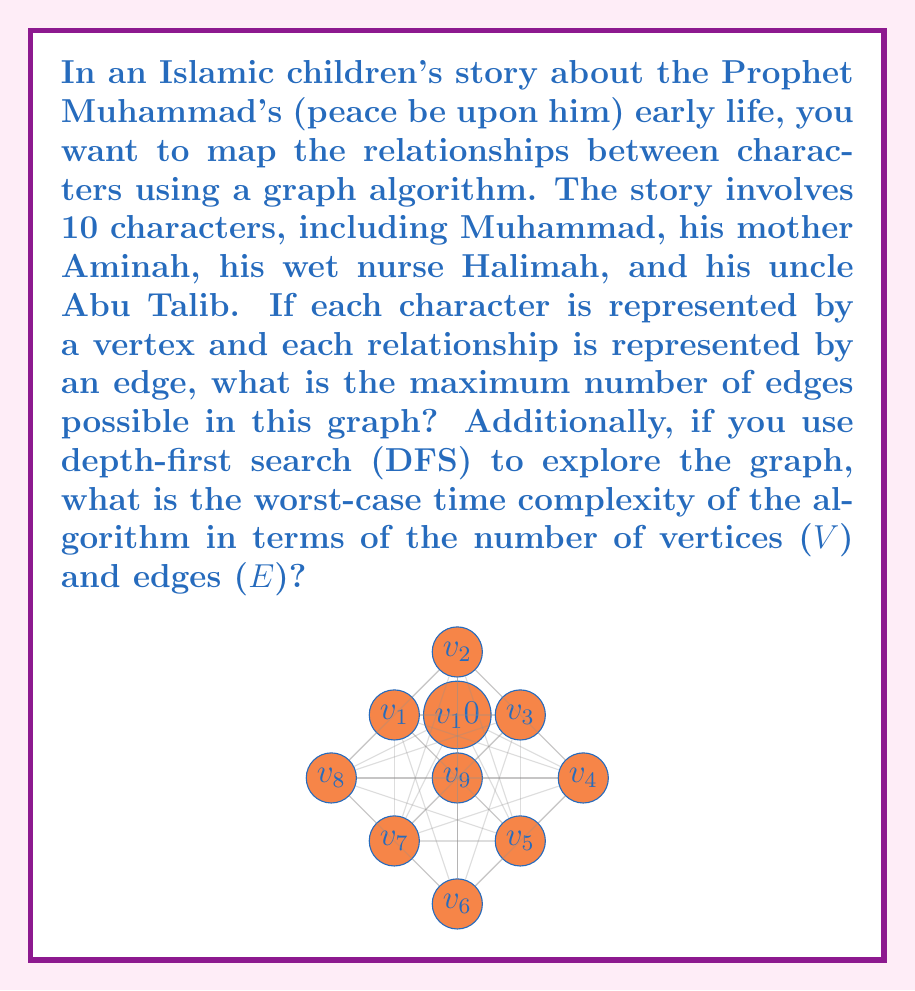Show me your answer to this math problem. Let's approach this problem step by step:

1. Maximum number of edges:
   - In an undirected graph with n vertices, the maximum number of edges occurs when every vertex is connected to every other vertex (except itself).
   - The formula for the maximum number of edges in an undirected graph is:
     $$ E_{max} = \frac{n(n-1)}{2} $$
   - In this case, n = 10 (number of characters)
   - Substituting into the formula:
     $$ E_{max} = \frac{10(10-1)}{2} = \frac{10 \times 9}{2} = 45 $$

2. Worst-case time complexity of DFS:
   - The time complexity of DFS depends on how the graph is represented.
   - For an adjacency list representation:
     - Each vertex is visited once: O(V)
     - Each edge is explored once: O(E)
   - Therefore, the overall time complexity is:
     $$ O(V + E) $$
   - In the worst case, when the graph is complete (maximum number of edges):
     $$ E = \frac{V(V-1)}{2} \approx V^2 $$
   - Substituting this into the time complexity:
     $$ O(V + V^2) = O(V^2) $$

Thus, the worst-case time complexity of DFS for this graph is O(V^2).
Answer: 45 edges; O(V^2) 